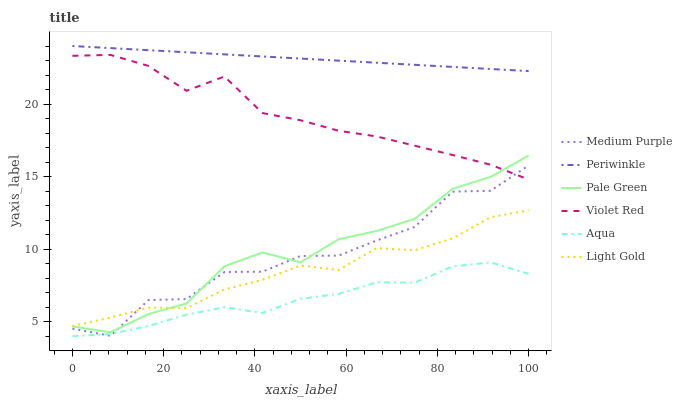Does Aqua have the minimum area under the curve?
Answer yes or no. Yes. Does Periwinkle have the maximum area under the curve?
Answer yes or no. Yes. Does Medium Purple have the minimum area under the curve?
Answer yes or no. No. Does Medium Purple have the maximum area under the curve?
Answer yes or no. No. Is Periwinkle the smoothest?
Answer yes or no. Yes. Is Medium Purple the roughest?
Answer yes or no. Yes. Is Aqua the smoothest?
Answer yes or no. No. Is Aqua the roughest?
Answer yes or no. No. Does Aqua have the lowest value?
Answer yes or no. Yes. Does Medium Purple have the lowest value?
Answer yes or no. No. Does Periwinkle have the highest value?
Answer yes or no. Yes. Does Medium Purple have the highest value?
Answer yes or no. No. Is Light Gold less than Periwinkle?
Answer yes or no. Yes. Is Light Gold greater than Aqua?
Answer yes or no. Yes. Does Pale Green intersect Medium Purple?
Answer yes or no. Yes. Is Pale Green less than Medium Purple?
Answer yes or no. No. Is Pale Green greater than Medium Purple?
Answer yes or no. No. Does Light Gold intersect Periwinkle?
Answer yes or no. No. 